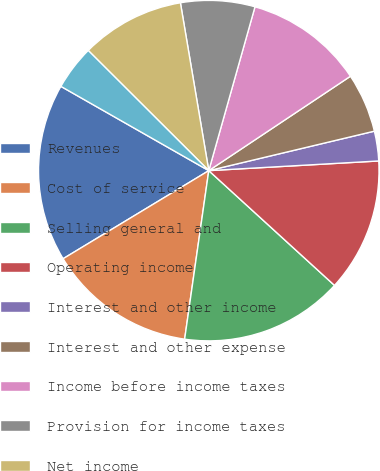<chart> <loc_0><loc_0><loc_500><loc_500><pie_chart><fcel>Revenues<fcel>Cost of service<fcel>Selling general and<fcel>Operating income<fcel>Interest and other income<fcel>Interest and other expense<fcel>Income before income taxes<fcel>Provision for income taxes<fcel>Net income<fcel>Less Net income attributable<nl><fcel>16.9%<fcel>14.08%<fcel>15.49%<fcel>12.68%<fcel>2.82%<fcel>5.63%<fcel>11.27%<fcel>7.04%<fcel>9.86%<fcel>4.23%<nl></chart> 